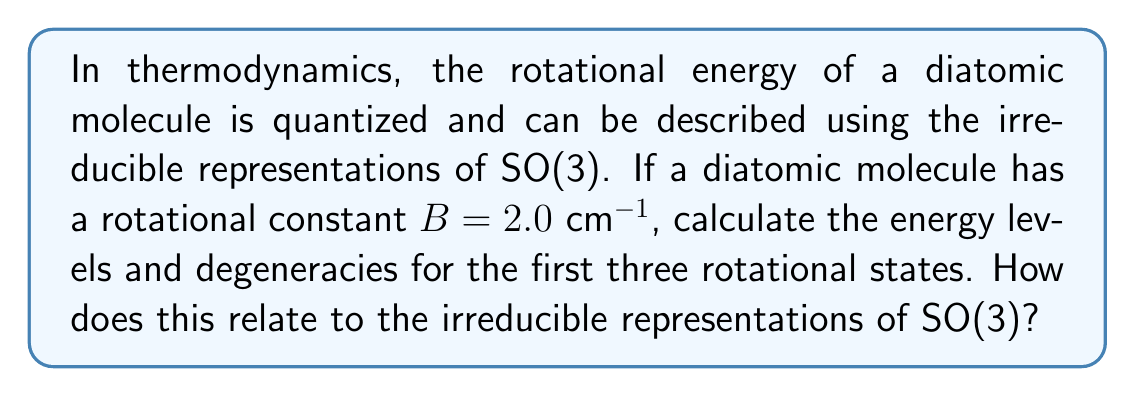Can you solve this math problem? 1. The irreducible representations of SO(3) are characterized by angular momentum quantum number $j$, with dimension $2j+1$.

2. For a rigid rotor (diatomic molecule), the rotational energy levels are given by:
   $$E_j = BJ(J+1)$$
   where $B$ is the rotational constant and $J$ is the rotational quantum number.

3. Calculate the energy levels for $J = 0, 1, 2$:
   - $J = 0$: $E_0 = 0 \text{ cm}^{-1}$
   - $J = 1$: $E_1 = 2B = 4 \text{ cm}^{-1}$
   - $J = 2$: $E_2 = 6B = 12 \text{ cm}^{-1}$

4. The degeneracy of each level is $2J+1$, corresponding to the dimension of the irreducible representation:
   - $J = 0$: degeneracy = 1
   - $J = 1$: degeneracy = 3
   - $J = 2$: degeneracy = 5

5. These degeneracies correspond to the dimensions of the irreducible representations of SO(3):
   - $J = 0$: 1-dimensional representation (scalar)
   - $J = 1$: 3-dimensional representation (vector)
   - $J = 2$: 5-dimensional representation (traceless symmetric tensor)

6. The connection to angular momentum: Each $J$ value corresponds to a total angular momentum state, and the $2J+1$ degeneracy represents the possible $m_J$ values (projections of angular momentum along a chosen axis).
Answer: Energy levels: 0, 4, 12 $\text{cm}^{-1}$; Degeneracies: 1, 3, 5; Corresponding to 1D, 3D, and 5D irreducible representations of SO(3). 